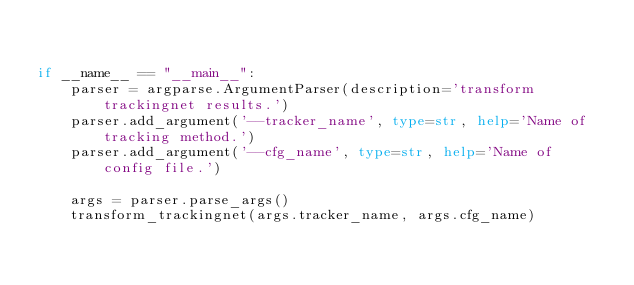<code> <loc_0><loc_0><loc_500><loc_500><_Python_>

if __name__ == "__main__":
    parser = argparse.ArgumentParser(description='transform trackingnet results.')
    parser.add_argument('--tracker_name', type=str, help='Name of tracking method.')
    parser.add_argument('--cfg_name', type=str, help='Name of config file.')

    args = parser.parse_args()
    transform_trackingnet(args.tracker_name, args.cfg_name)
</code> 